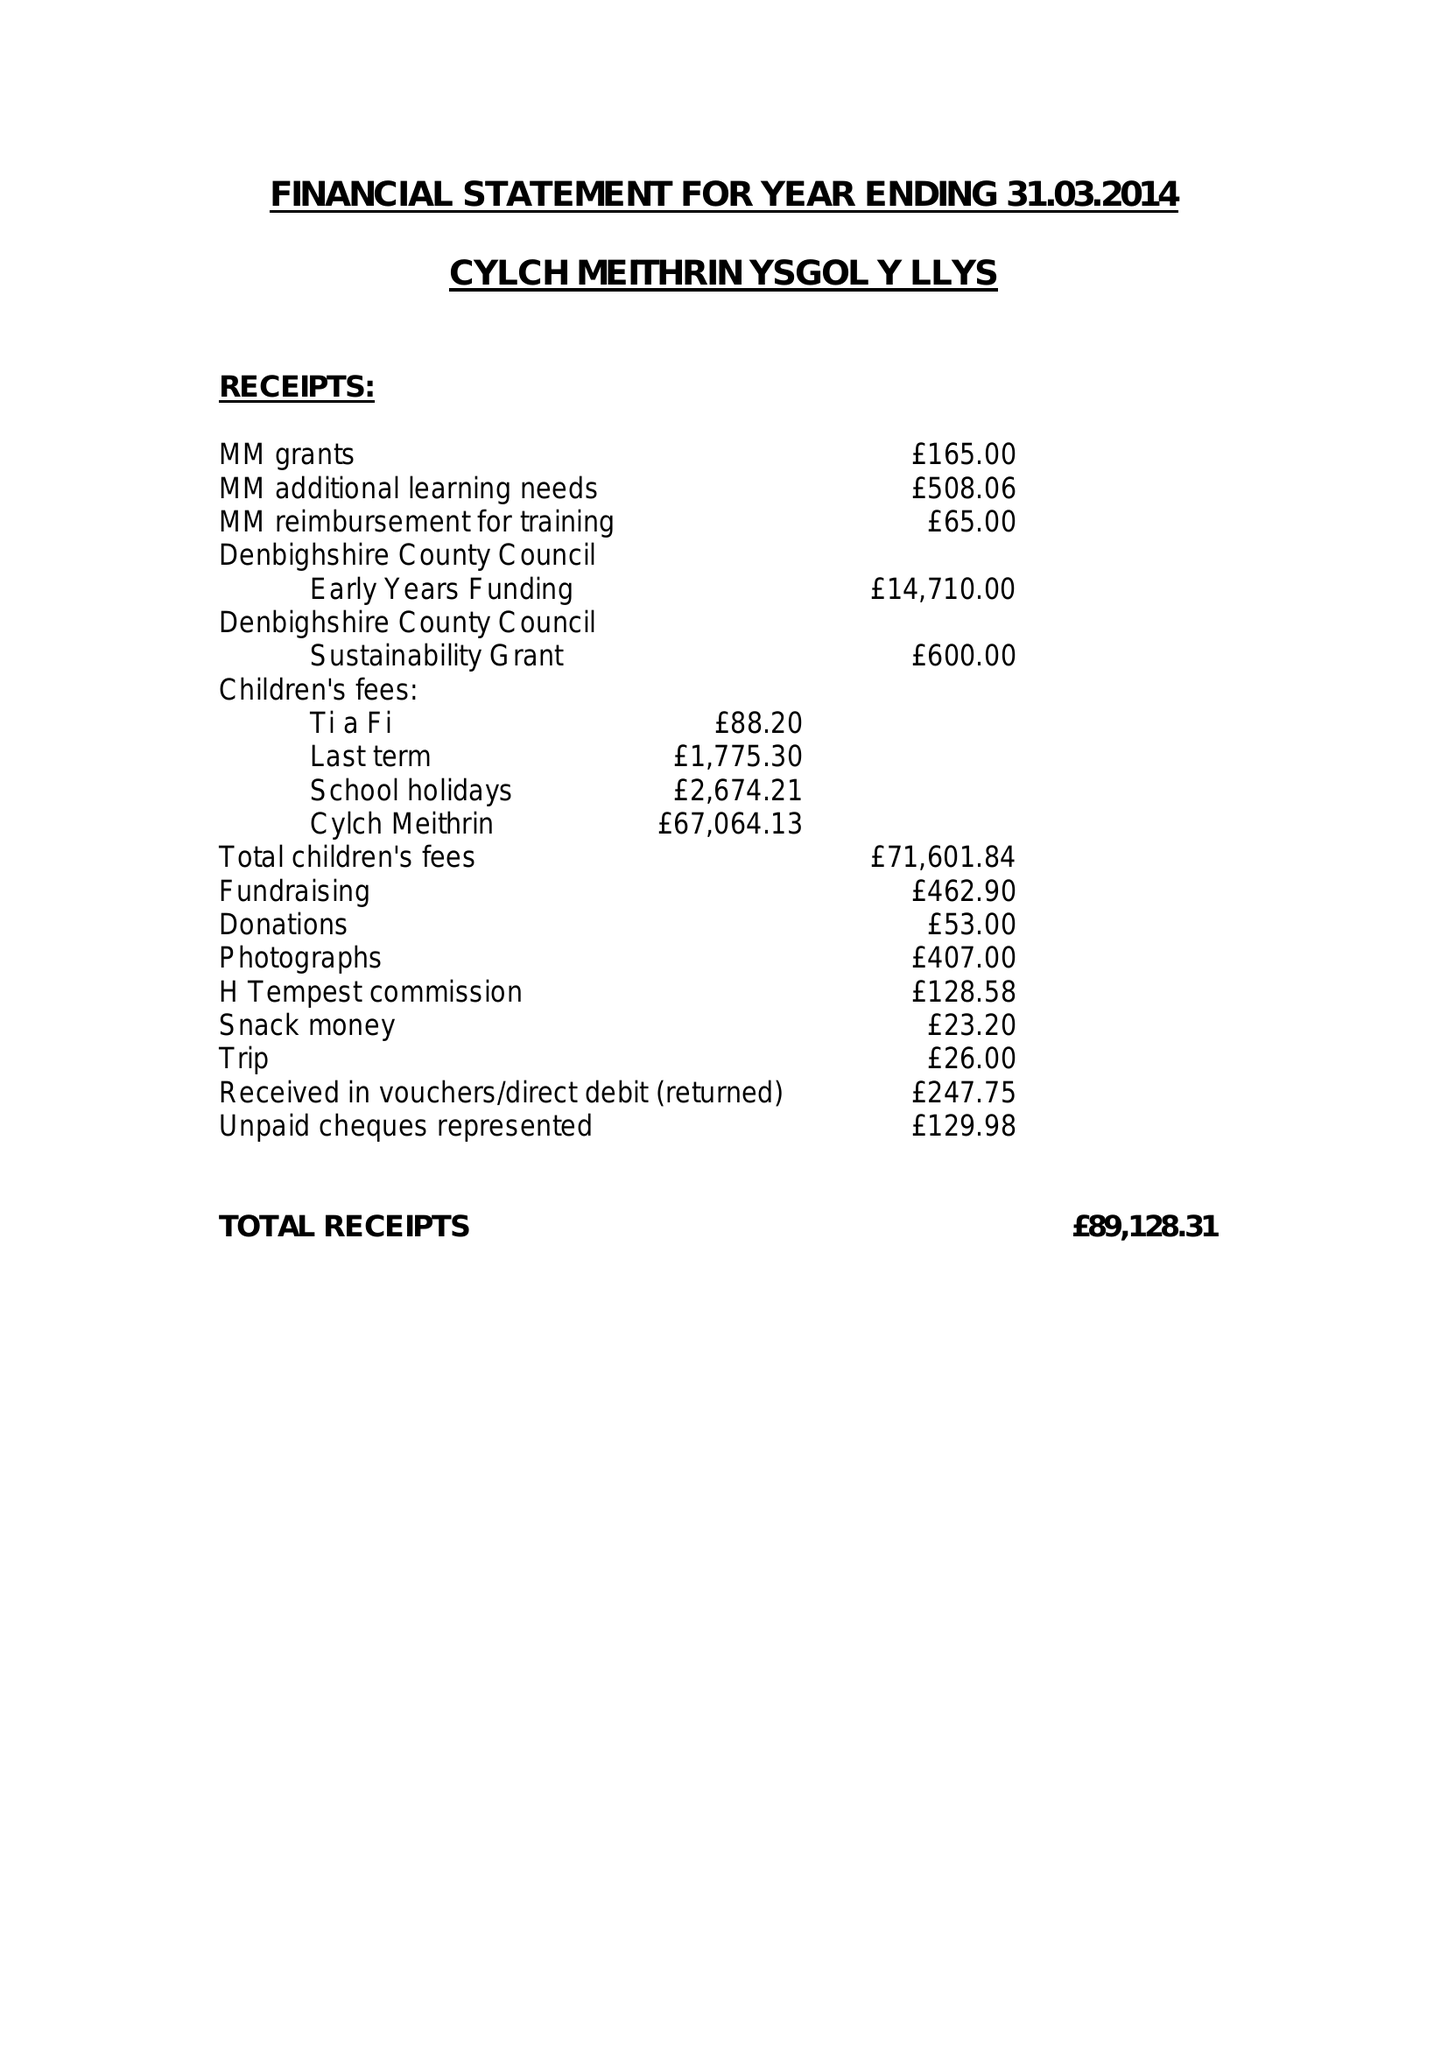What is the value for the report_date?
Answer the question using a single word or phrase. 2014-03-31 